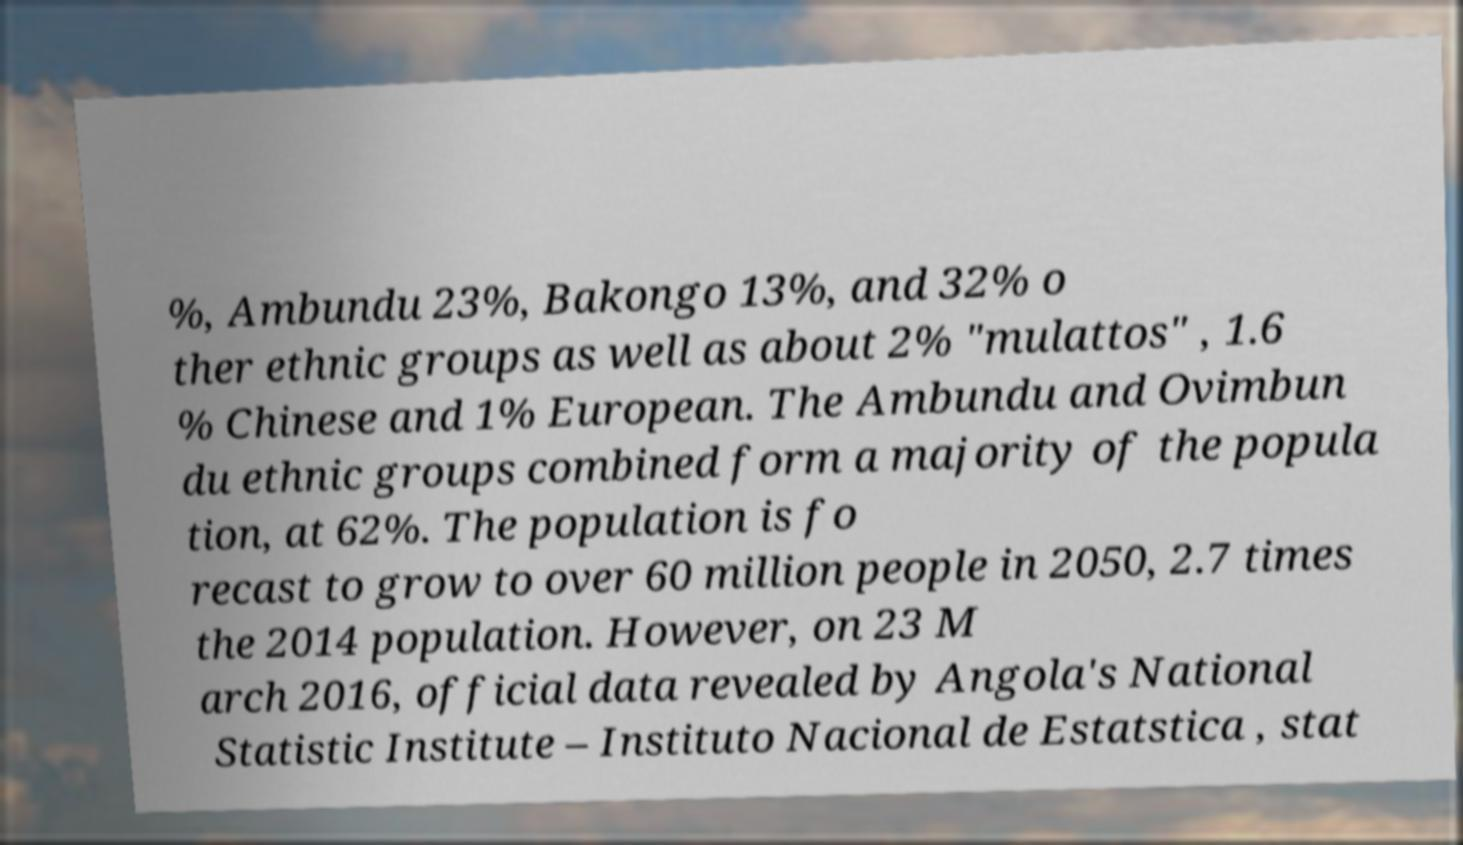Can you accurately transcribe the text from the provided image for me? %, Ambundu 23%, Bakongo 13%, and 32% o ther ethnic groups as well as about 2% "mulattos" , 1.6 % Chinese and 1% European. The Ambundu and Ovimbun du ethnic groups combined form a majority of the popula tion, at 62%. The population is fo recast to grow to over 60 million people in 2050, 2.7 times the 2014 population. However, on 23 M arch 2016, official data revealed by Angola's National Statistic Institute – Instituto Nacional de Estatstica , stat 